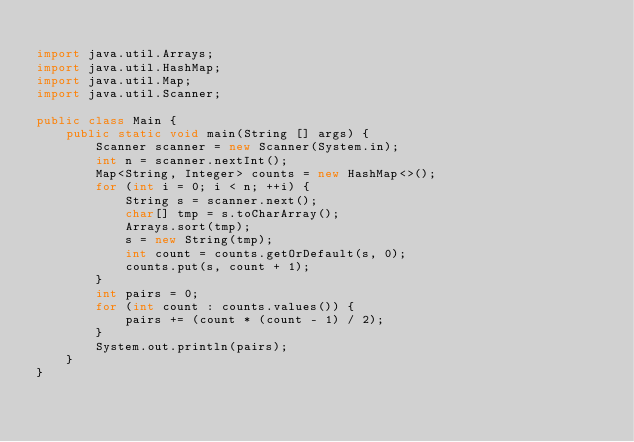<code> <loc_0><loc_0><loc_500><loc_500><_Java_>
import java.util.Arrays;
import java.util.HashMap;
import java.util.Map;
import java.util.Scanner;

public class Main {
    public static void main(String [] args) {
        Scanner scanner = new Scanner(System.in);
        int n = scanner.nextInt();
        Map<String, Integer> counts = new HashMap<>();
        for (int i = 0; i < n; ++i) {
            String s = scanner.next();
            char[] tmp = s.toCharArray();
            Arrays.sort(tmp);
            s = new String(tmp);
            int count = counts.getOrDefault(s, 0);
            counts.put(s, count + 1);
        }
        int pairs = 0;
        for (int count : counts.values()) {
            pairs += (count * (count - 1) / 2);
        }
        System.out.println(pairs);
    }
}</code> 